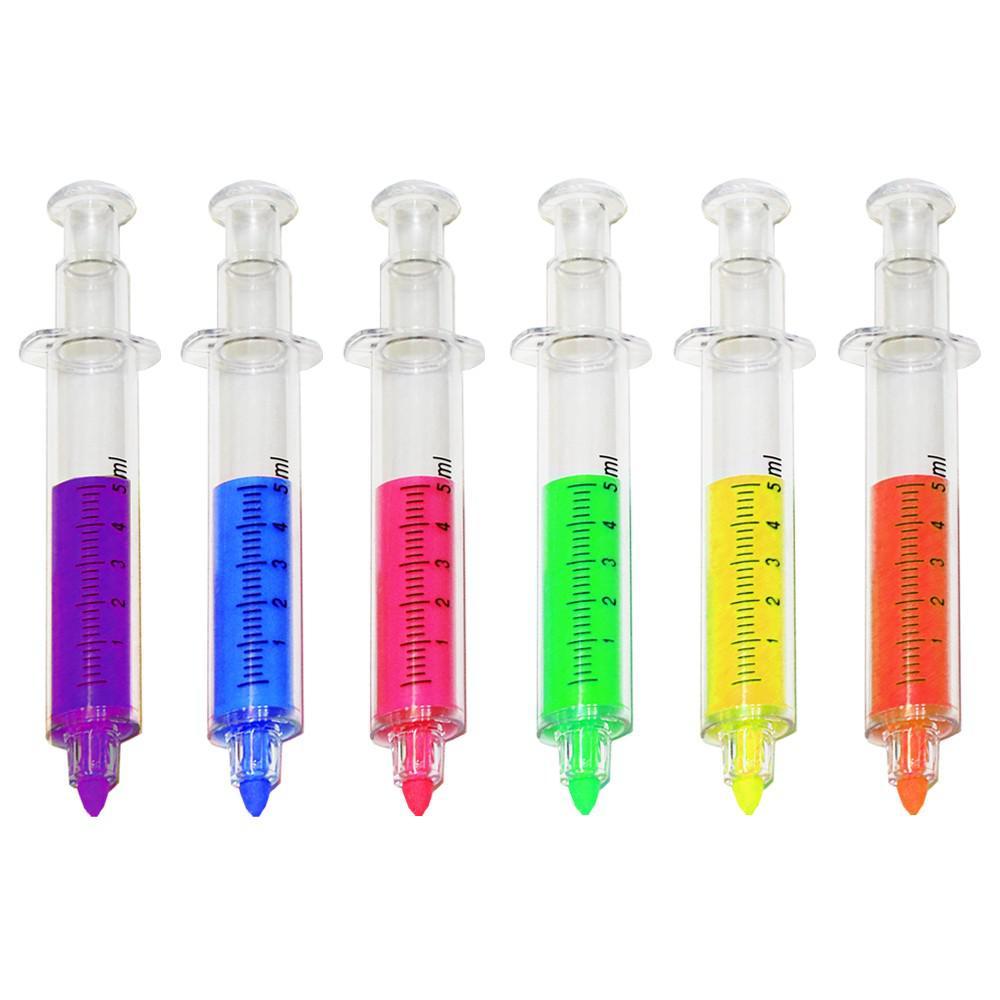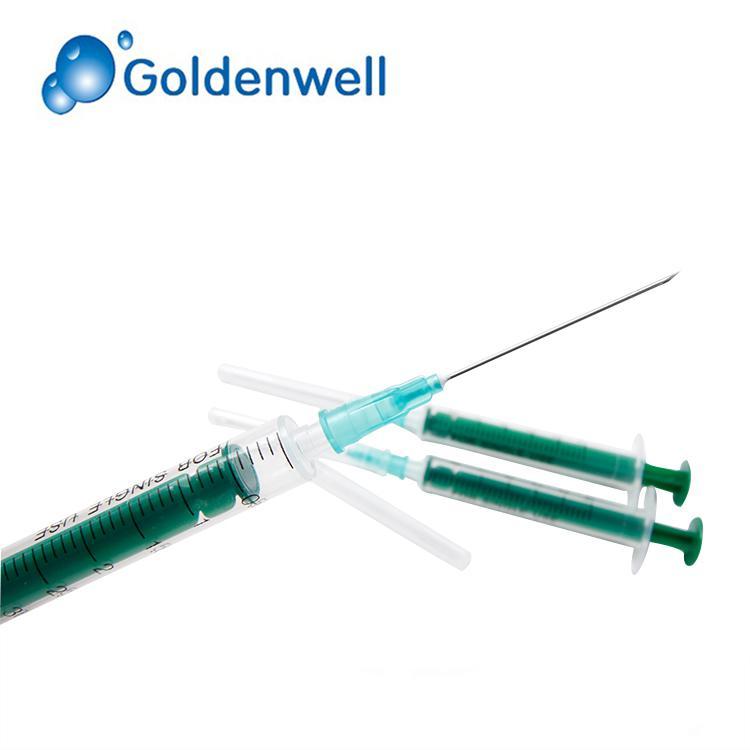The first image is the image on the left, the second image is the image on the right. Analyze the images presented: Is the assertion "The left and right image contains a total of nine syringes." valid? Answer yes or no. Yes. The first image is the image on the left, the second image is the image on the right. Examine the images to the left and right. Is the description "The left image is a row of needless syringes pointed downward." accurate? Answer yes or no. Yes. 